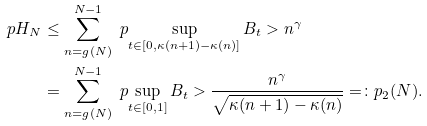Convert formula to latex. <formula><loc_0><loc_0><loc_500><loc_500>\ p { H _ { N } } & \leq \sum _ { n = g ( N ) } ^ { N - 1 } \ p { \sup _ { t \in [ 0 , \kappa ( n + 1 ) - \kappa ( n ) ] } B _ { t } > n ^ { \gamma } } \\ & = \sum _ { n = g ( N ) } ^ { N - 1 } \ p { \sup _ { t \in [ 0 , 1 ] } B _ { t } > \frac { n ^ { \gamma } } { \sqrt { \kappa ( n + 1 ) - \kappa ( n ) } } } = \colon p _ { 2 } ( N ) .</formula> 